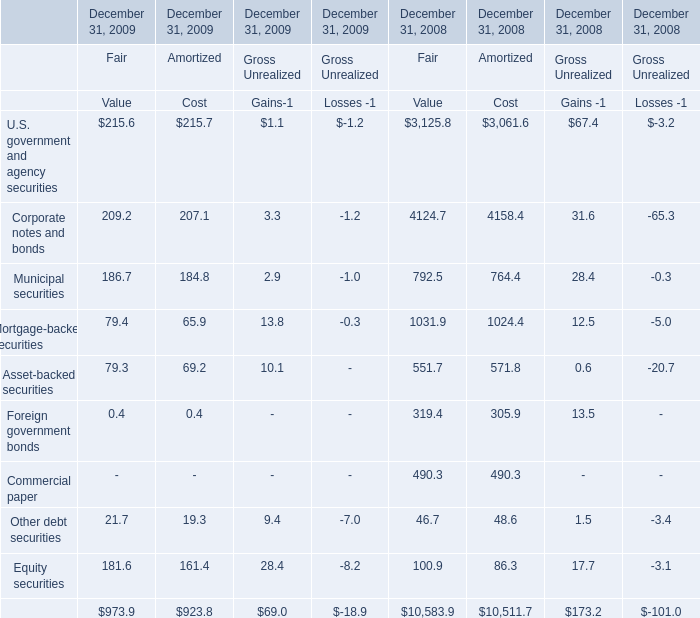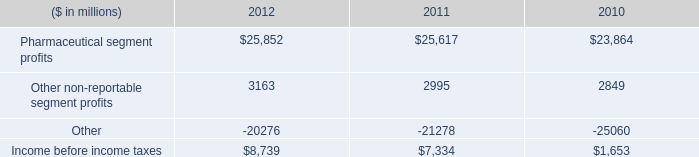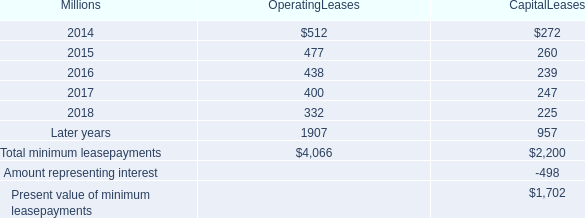what was the percentage change in rent expense for operating leases with terms exceeding one month from 2012 to 2013? 
Computations: ((618 - 631) / 631)
Answer: -0.0206. 